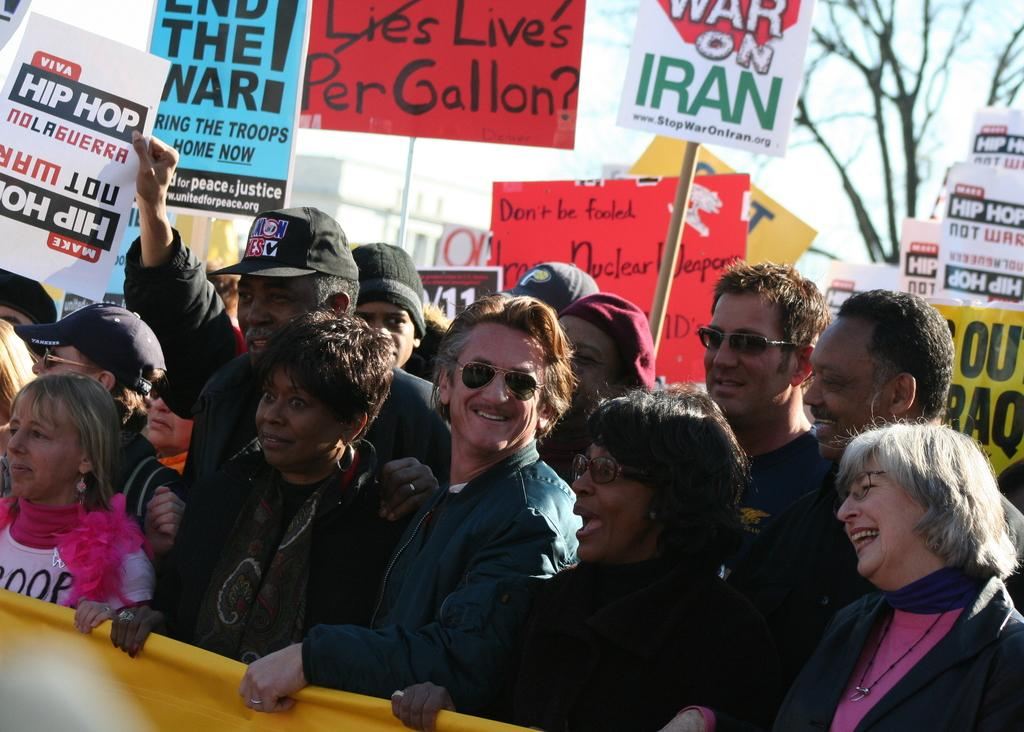How many people are in the image? There is a group of people in the image, but the exact number is not specified. What are the people doing in the image? The people are standing in the image. What are the people holding in the image? The people are holding an object in the image. What can be seen in the top right corner of the image? There is a tree at the top right of the image. How many cows are grazing in the field behind the people in the image? There is no field or cows visible in the image. 